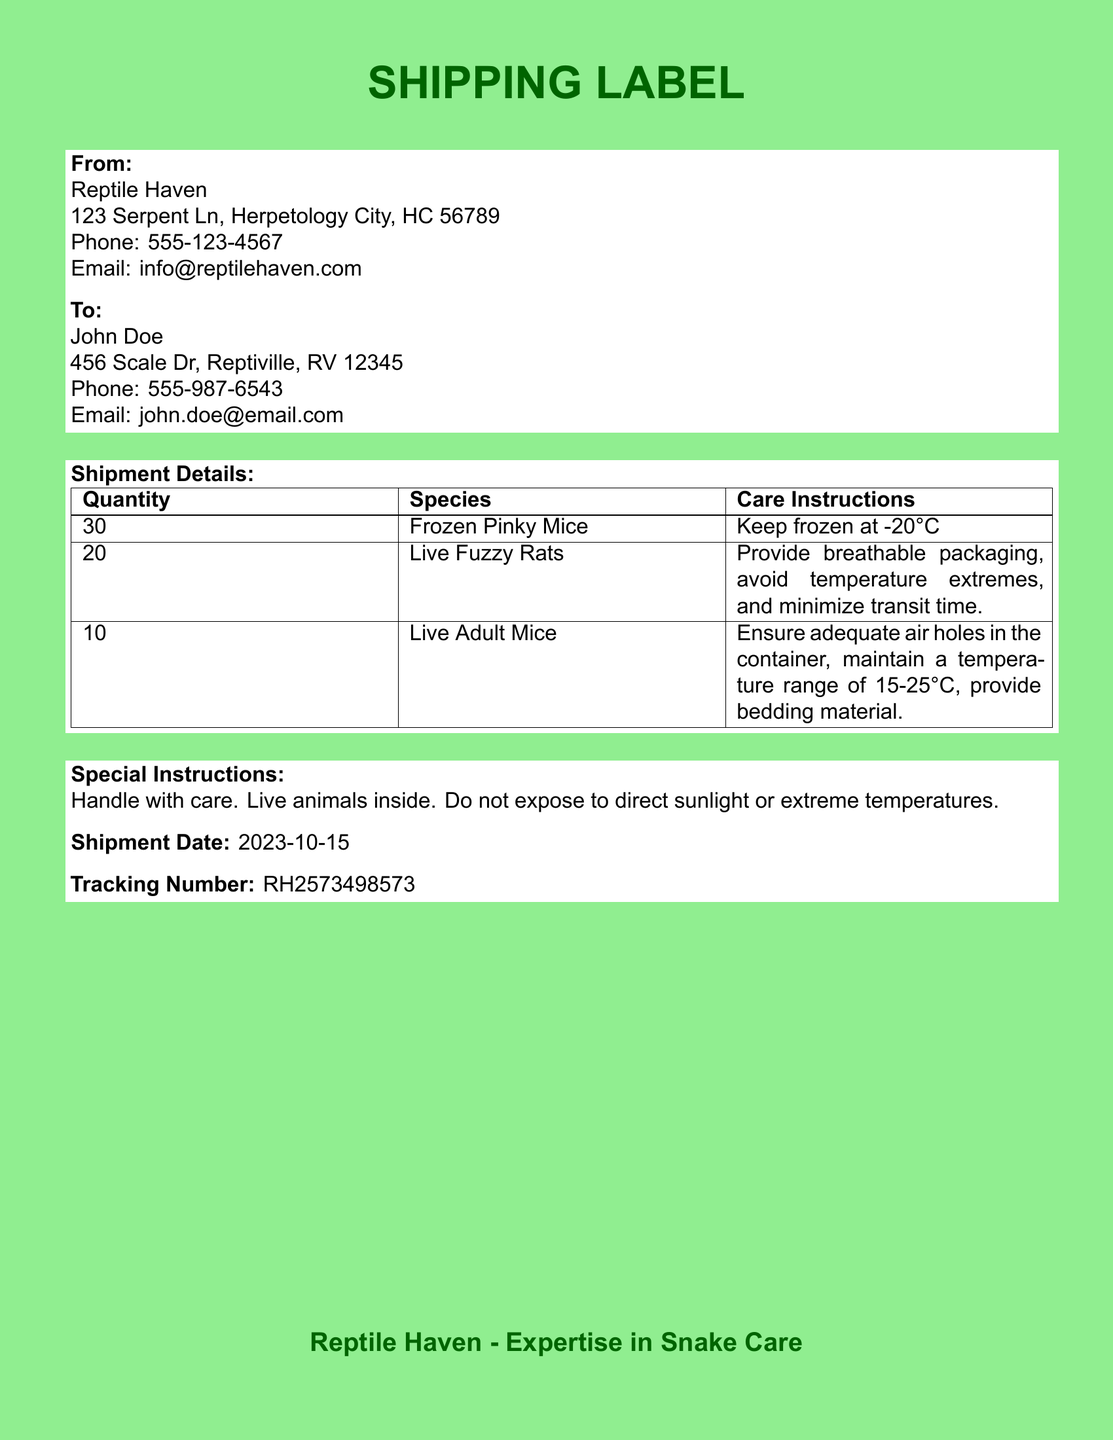What is the shipment date? The shipment date is specified in the document under 'Shipment Date.' It is listed as 2023-10-15.
Answer: 2023-10-15 How many live fuzzy rats are included? The document states the quantity of live fuzzy rats under the 'Shipment Details' section. The specified quantity is 20.
Answer: 20 What is the phone number for Reptile Haven? The phone number for Reptile Haven is found in the 'From' section of the document, which indicates the contact number.
Answer: 555-123-4567 What type of care instructions are given for live adult mice? The care instructions for live adult mice are listed in the table under 'Care Instructions.' They specify what to do for proper care during transit.
Answer: Ensure adequate air holes in the container, maintain a temperature range of 15-25°C, provide bedding material Who is the recipient of the shipment? The recipient is mentioned in the 'To' section of the document, which highlights the details of who will receive the delivery.
Answer: John Doe What is the tracking number for the shipment? The tracking number is provided at the end of the document, listed under 'Tracking Number.'
Answer: RH2573498573 How many frozen pinky mice are being shipped? The quantity of frozen pinky mice is specified in the 'Shipment Details' table in the document.
Answer: 30 What special instructions are provided for handling the shipment? The special instructions can be found in a dedicated section that discusses precautions to take with the shipment.
Answer: Handle with care. Live animals inside. Do not expose to direct sunlight or extreme temperatures 